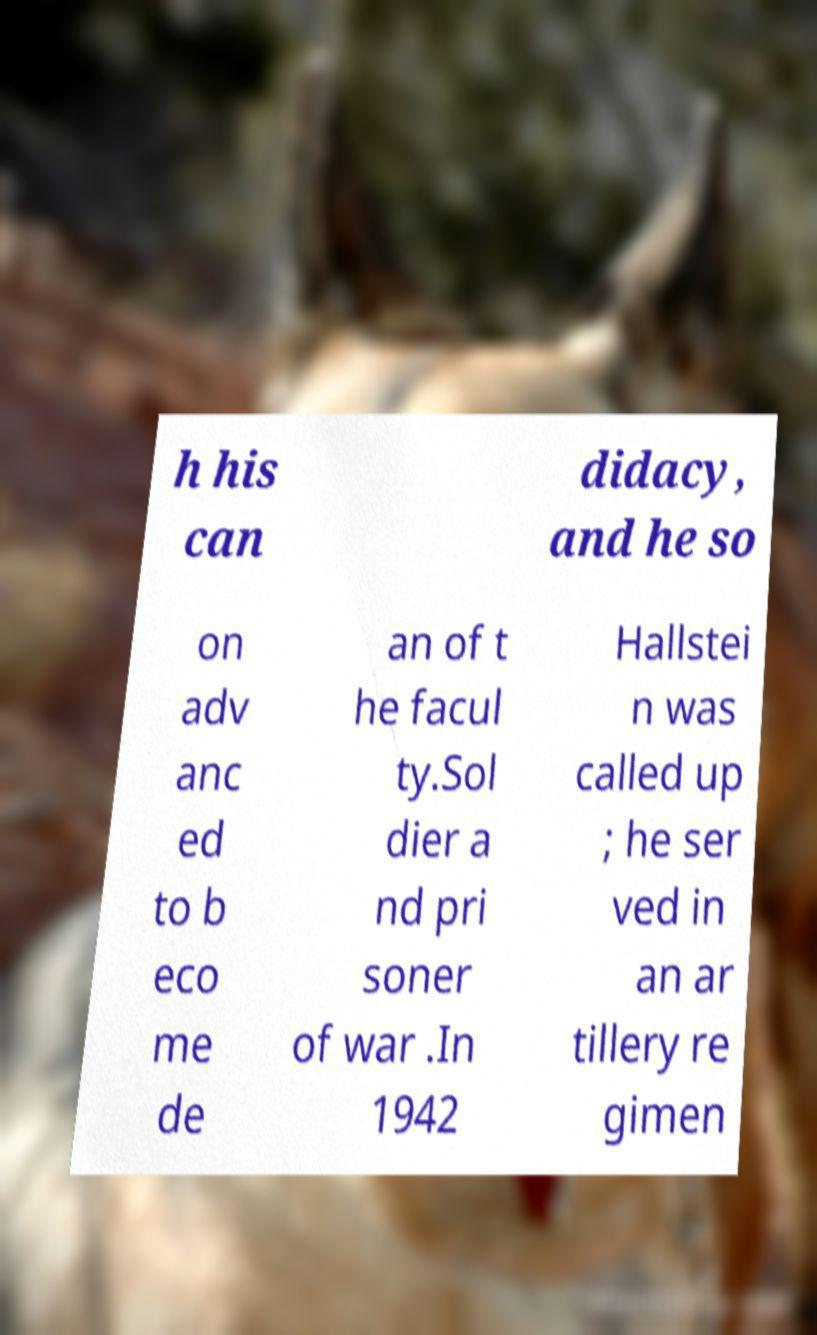There's text embedded in this image that I need extracted. Can you transcribe it verbatim? h his can didacy, and he so on adv anc ed to b eco me de an of t he facul ty.Sol dier a nd pri soner of war .In 1942 Hallstei n was called up ; he ser ved in an ar tillery re gimen 